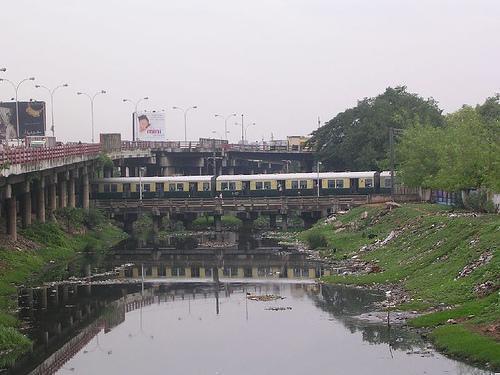What is the problem in this area?
Select the accurate response from the four choices given to answer the question.
Options: Water shortage, traffic congestion, water pollution, landslide. Water pollution. 